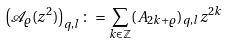<formula> <loc_0><loc_0><loc_500><loc_500>\left ( \mathcal { A } _ { \varrho } ( z ^ { 2 } ) \right ) _ { q , l } \colon = \sum _ { k \in \mathbb { Z } } ( A _ { 2 k + \varrho } ) _ { q , l } z ^ { 2 k }</formula> 